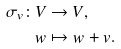<formula> <loc_0><loc_0><loc_500><loc_500>\sigma _ { v } \colon V & \to V , \\ w & \mapsto w + v .</formula> 